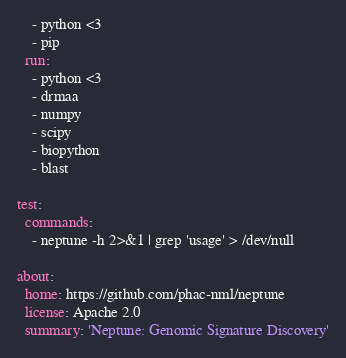<code> <loc_0><loc_0><loc_500><loc_500><_YAML_>    - python <3
    - pip
  run:
    - python <3
    - drmaa
    - numpy
    - scipy
    - biopython
    - blast

test:
  commands:
    - neptune -h 2>&1 | grep 'usage' > /dev/null

about:
  home: https://github.com/phac-nml/neptune
  license: Apache 2.0
  summary: 'Neptune: Genomic Signature Discovery'
</code> 